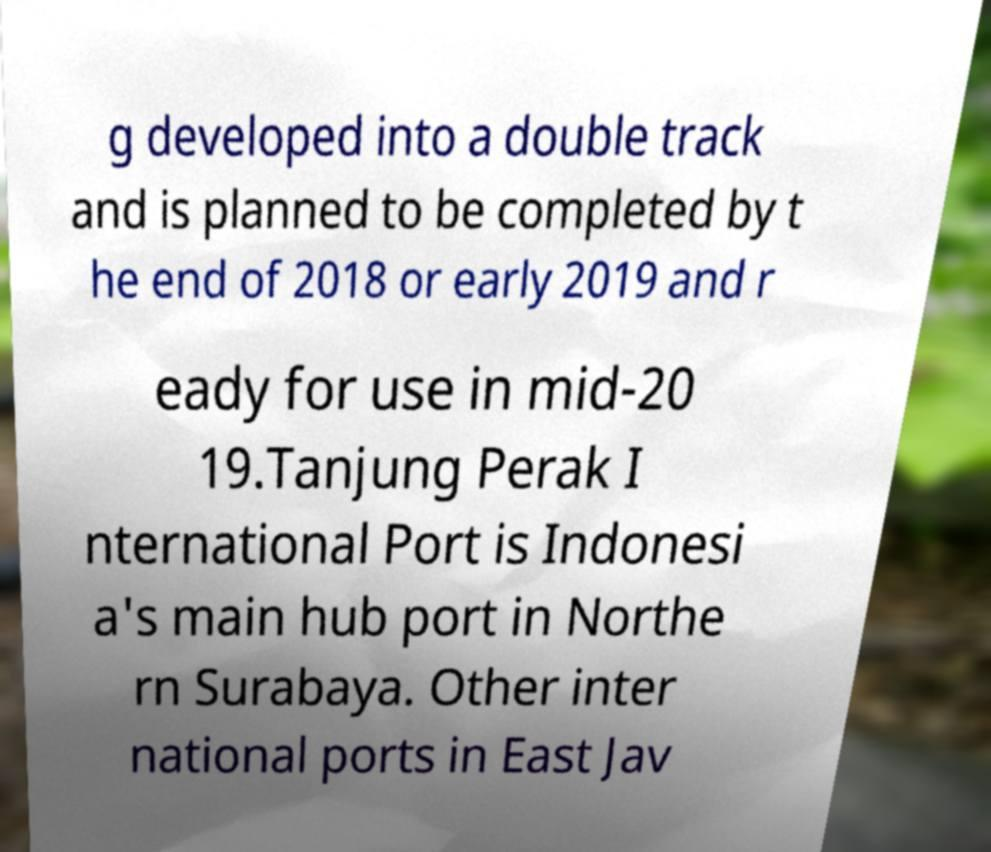Please read and relay the text visible in this image. What does it say? g developed into a double track and is planned to be completed by t he end of 2018 or early 2019 and r eady for use in mid-20 19.Tanjung Perak I nternational Port is Indonesi a's main hub port in Northe rn Surabaya. Other inter national ports in East Jav 